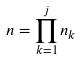Convert formula to latex. <formula><loc_0><loc_0><loc_500><loc_500>n = \prod _ { k = 1 } ^ { j } n _ { k }</formula> 